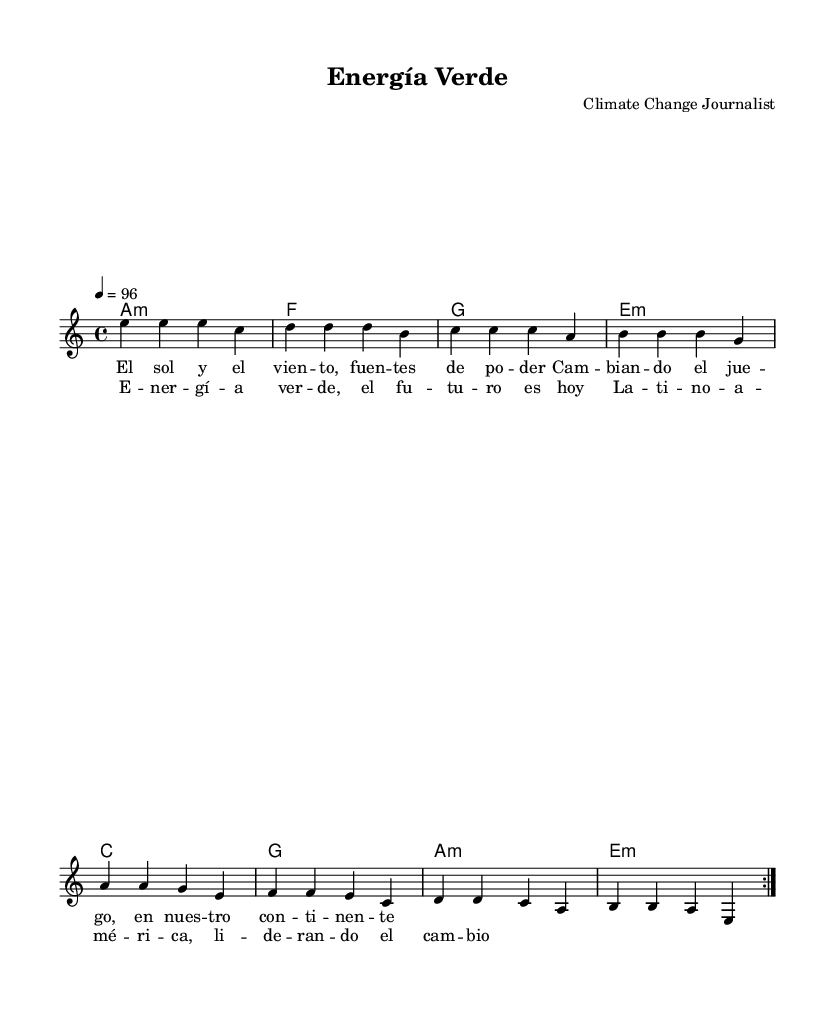What is the key signature of this music? The key signature is indicated at the beginning of the score with the letter 'A' and a minor designation, which means it has no sharps or flats.
Answer: A minor What is the time signature of this music? The time signature is displayed in the beginning, consisting of a '4' on top of a '4', indicating that there are four beats in each measure and the quarter note gets one beat.
Answer: 4/4 What is the tempo marking of this music? The tempo marking is shown in the score with '4 = 96', meaning there are 96 beats per minute and that a quarter note equals one beat.
Answer: 96 How many verses are in the song? The score shows the lyrics, where the section labeled 'verse' consists of two stanzas along with the chorus, indicating two verses are present in this song structure.
Answer: 2 What is the primary theme of the lyrics? The lyrics focus on renewable energy, specifically emphasizing solar power and climate change, indicating that the song promotes a message about environmental issues and sustainable practices.
Answer: Renewable energy What chords accompany the melody? The chord names listed in the 'ChordNames' section provide the harmonies to be played, including A minor, F, G, E minor, C, and G, which are indicated above the melody notes in the score.
Answer: A minor, F, G, E minor, C, G What is the title of the music? The title is found at the header of the sheet music and it is presented as 'Energía Verde', which suggests a connection to green energy themes reflected in the lyrics and overall message of the piece.
Answer: Energía Verde 